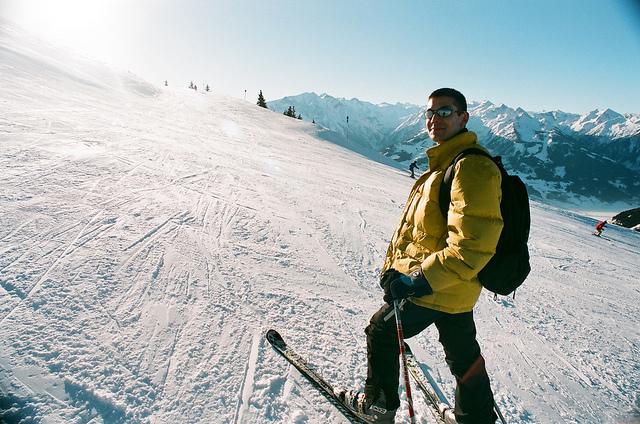Is it night time?
Write a very short answer. No. What color coat is the person on the right wearing?
Give a very brief answer. Yellow. Does this area look well-skied?
Give a very brief answer. Yes. 